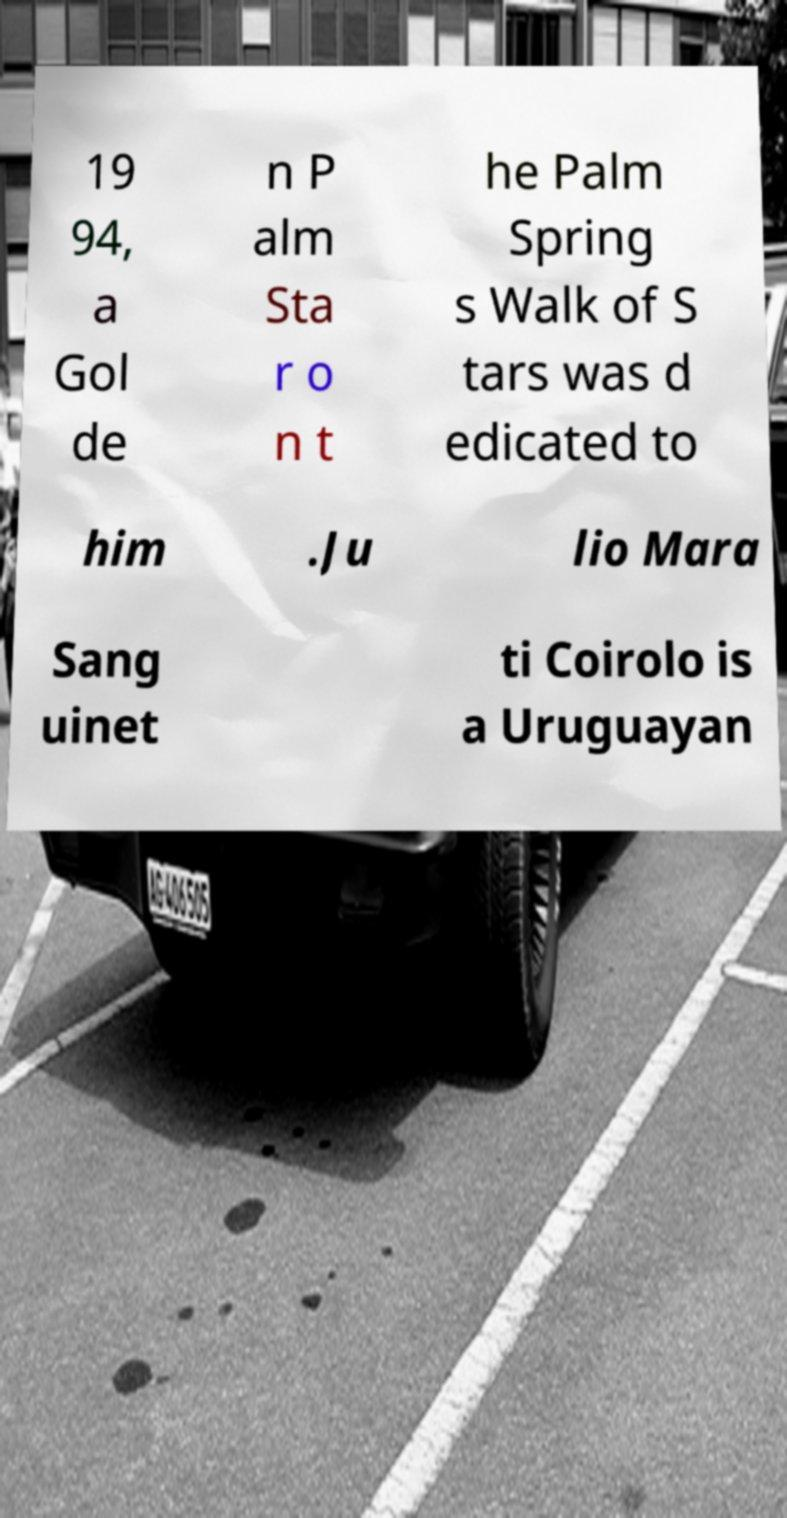Can you read and provide the text displayed in the image?This photo seems to have some interesting text. Can you extract and type it out for me? 19 94, a Gol de n P alm Sta r o n t he Palm Spring s Walk of S tars was d edicated to him .Ju lio Mara Sang uinet ti Coirolo is a Uruguayan 